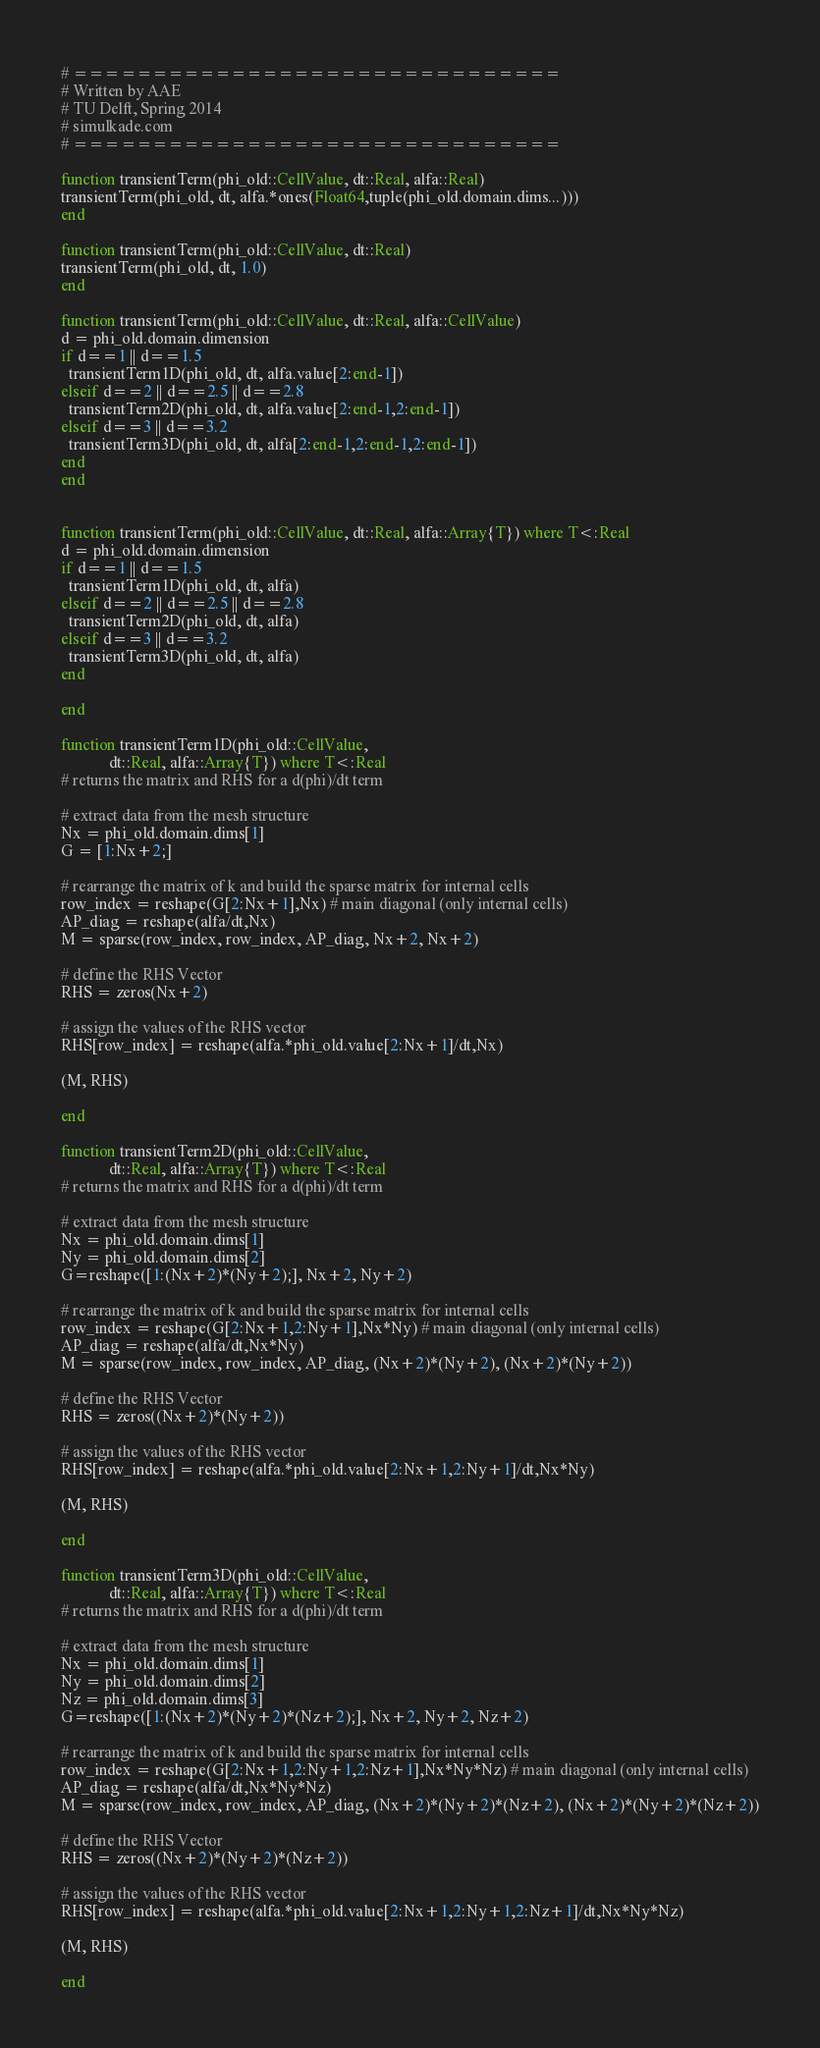Convert code to text. <code><loc_0><loc_0><loc_500><loc_500><_Julia_># ===============================
# Written by AAE
# TU Delft, Spring 2014
# simulkade.com
# ===============================

function transientTerm(phi_old::CellValue, dt::Real, alfa::Real)
transientTerm(phi_old, dt, alfa.*ones(Float64,tuple(phi_old.domain.dims...)))
end

function transientTerm(phi_old::CellValue, dt::Real)
transientTerm(phi_old, dt, 1.0)
end

function transientTerm(phi_old::CellValue, dt::Real, alfa::CellValue)
d = phi_old.domain.dimension
if d==1 || d==1.5
  transientTerm1D(phi_old, dt, alfa.value[2:end-1])
elseif d==2 || d==2.5 || d==2.8
  transientTerm2D(phi_old, dt, alfa.value[2:end-1,2:end-1])
elseif d==3 || d==3.2
  transientTerm3D(phi_old, dt, alfa[2:end-1,2:end-1,2:end-1])
end
end


function transientTerm(phi_old::CellValue, dt::Real, alfa::Array{T}) where T<:Real
d = phi_old.domain.dimension
if d==1 || d==1.5
  transientTerm1D(phi_old, dt, alfa)
elseif d==2 || d==2.5 || d==2.8
  transientTerm2D(phi_old, dt, alfa)
elseif d==3 || d==3.2
  transientTerm3D(phi_old, dt, alfa)
end

end

function transientTerm1D(phi_old::CellValue,
		    dt::Real, alfa::Array{T}) where T<:Real
# returns the matrix and RHS for a d(phi)/dt term

# extract data from the mesh structure
Nx = phi_old.domain.dims[1]
G = [1:Nx+2;]

# rearrange the matrix of k and build the sparse matrix for internal cells
row_index = reshape(G[2:Nx+1],Nx) # main diagonal (only internal cells)
AP_diag = reshape(alfa/dt,Nx)
M = sparse(row_index, row_index, AP_diag, Nx+2, Nx+2)

# define the RHS Vector
RHS = zeros(Nx+2)

# assign the values of the RHS vector
RHS[row_index] = reshape(alfa.*phi_old.value[2:Nx+1]/dt,Nx)

(M, RHS)

end

function transientTerm2D(phi_old::CellValue,
		    dt::Real, alfa::Array{T}) where T<:Real
# returns the matrix and RHS for a d(phi)/dt term

# extract data from the mesh structure
Nx = phi_old.domain.dims[1]
Ny = phi_old.domain.dims[2]
G=reshape([1:(Nx+2)*(Ny+2);], Nx+2, Ny+2)

# rearrange the matrix of k and build the sparse matrix for internal cells
row_index = reshape(G[2:Nx+1,2:Ny+1],Nx*Ny) # main diagonal (only internal cells)
AP_diag = reshape(alfa/dt,Nx*Ny)
M = sparse(row_index, row_index, AP_diag, (Nx+2)*(Ny+2), (Nx+2)*(Ny+2))

# define the RHS Vector
RHS = zeros((Nx+2)*(Ny+2))

# assign the values of the RHS vector
RHS[row_index] = reshape(alfa.*phi_old.value[2:Nx+1,2:Ny+1]/dt,Nx*Ny)

(M, RHS)

end

function transientTerm3D(phi_old::CellValue,
		    dt::Real, alfa::Array{T}) where T<:Real
# returns the matrix and RHS for a d(phi)/dt term

# extract data from the mesh structure
Nx = phi_old.domain.dims[1]
Ny = phi_old.domain.dims[2]
Nz = phi_old.domain.dims[3]
G=reshape([1:(Nx+2)*(Ny+2)*(Nz+2);], Nx+2, Ny+2, Nz+2)

# rearrange the matrix of k and build the sparse matrix for internal cells
row_index = reshape(G[2:Nx+1,2:Ny+1,2:Nz+1],Nx*Ny*Nz) # main diagonal (only internal cells)
AP_diag = reshape(alfa/dt,Nx*Ny*Nz)
M = sparse(row_index, row_index, AP_diag, (Nx+2)*(Ny+2)*(Nz+2), (Nx+2)*(Ny+2)*(Nz+2))

# define the RHS Vector
RHS = zeros((Nx+2)*(Ny+2)*(Nz+2))

# assign the values of the RHS vector
RHS[row_index] = reshape(alfa.*phi_old.value[2:Nx+1,2:Ny+1,2:Nz+1]/dt,Nx*Ny*Nz)

(M, RHS)

end
</code> 